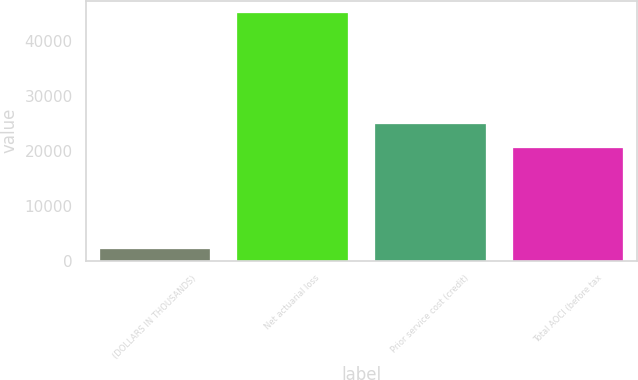<chart> <loc_0><loc_0><loc_500><loc_500><bar_chart><fcel>(DOLLARS IN THOUSANDS)<fcel>Net actuarial loss<fcel>Prior service cost (credit)<fcel>Total AOCI (before tax<nl><fcel>2011<fcel>44959<fcel>24813.8<fcel>20519<nl></chart> 